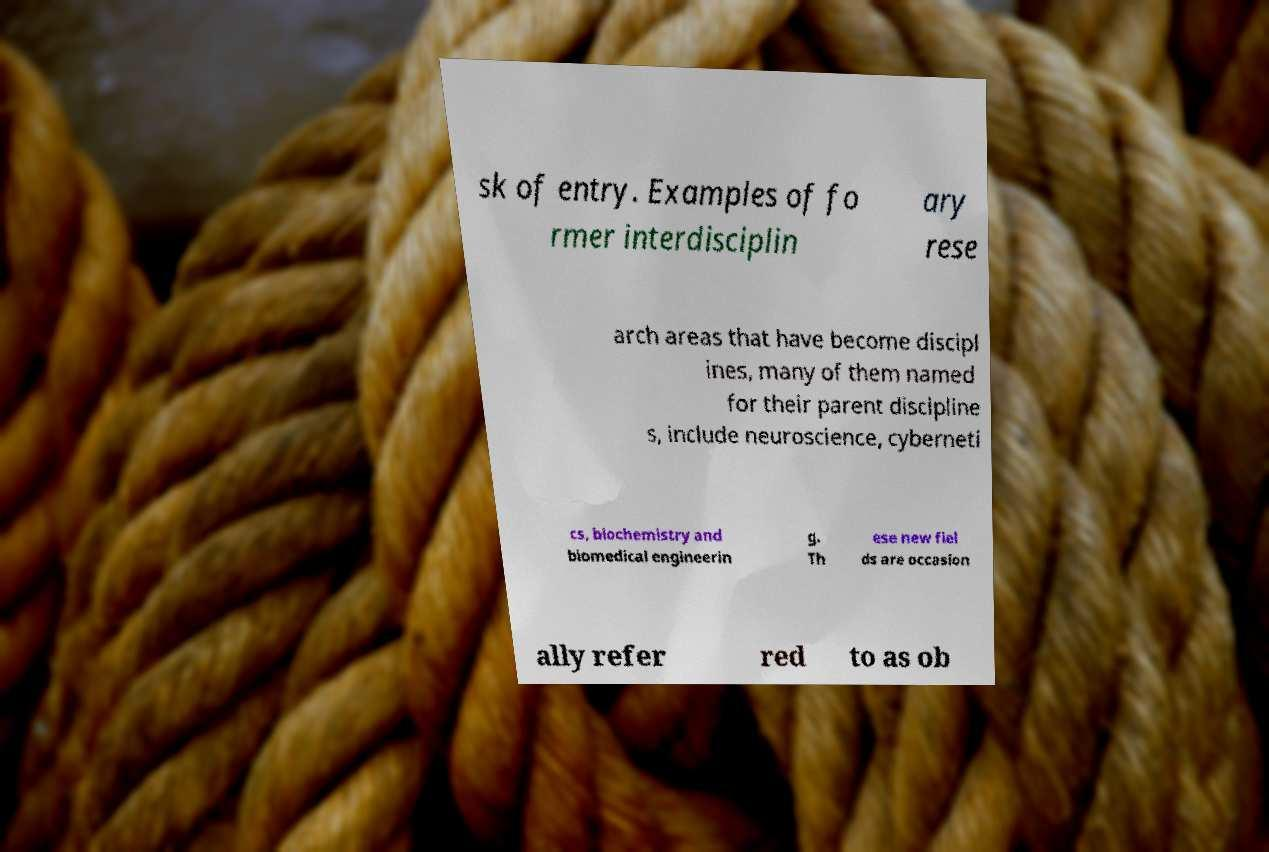What messages or text are displayed in this image? I need them in a readable, typed format. sk of entry. Examples of fo rmer interdisciplin ary rese arch areas that have become discipl ines, many of them named for their parent discipline s, include neuroscience, cyberneti cs, biochemistry and biomedical engineerin g. Th ese new fiel ds are occasion ally refer red to as ob 